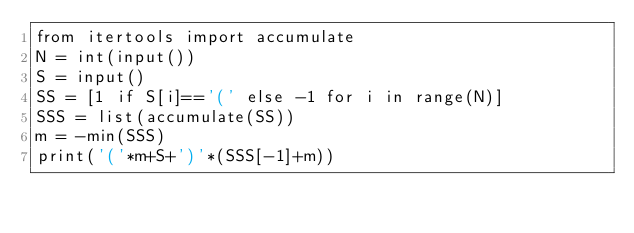<code> <loc_0><loc_0><loc_500><loc_500><_Python_>from itertools import accumulate
N = int(input())
S = input()
SS = [1 if S[i]=='(' else -1 for i in range(N)]
SSS = list(accumulate(SS))
m = -min(SSS)
print('('*m+S+')'*(SSS[-1]+m))
</code> 